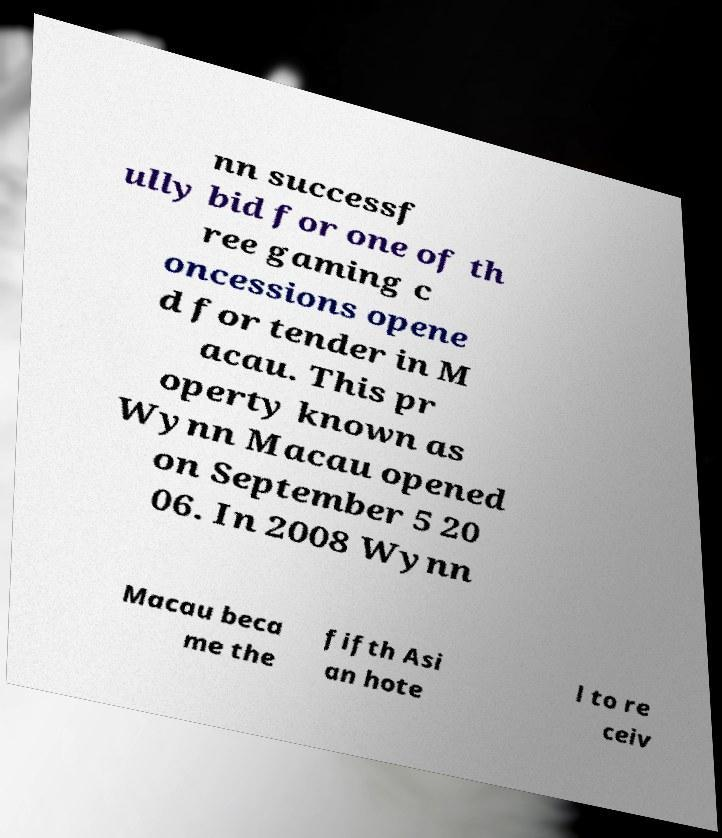Please identify and transcribe the text found in this image. nn successf ully bid for one of th ree gaming c oncessions opene d for tender in M acau. This pr operty known as Wynn Macau opened on September 5 20 06. In 2008 Wynn Macau beca me the fifth Asi an hote l to re ceiv 